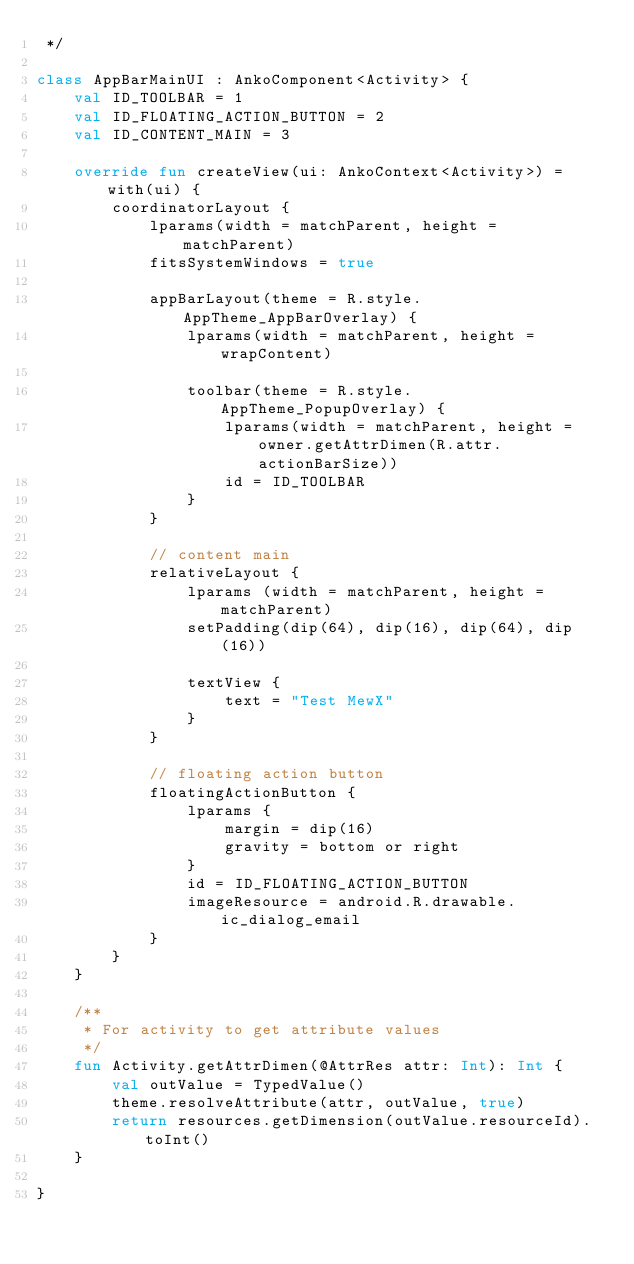<code> <loc_0><loc_0><loc_500><loc_500><_Kotlin_> */

class AppBarMainUI : AnkoComponent<Activity> {
    val ID_TOOLBAR = 1
    val ID_FLOATING_ACTION_BUTTON = 2
    val ID_CONTENT_MAIN = 3

    override fun createView(ui: AnkoContext<Activity>) = with(ui) {
        coordinatorLayout {
            lparams(width = matchParent, height = matchParent)
            fitsSystemWindows = true

            appBarLayout(theme = R.style.AppTheme_AppBarOverlay) {
                lparams(width = matchParent, height = wrapContent)

                toolbar(theme = R.style.AppTheme_PopupOverlay) {
                    lparams(width = matchParent, height = owner.getAttrDimen(R.attr.actionBarSize))
                    id = ID_TOOLBAR
                }
            }

            // content main
            relativeLayout {
                lparams (width = matchParent, height = matchParent)
                setPadding(dip(64), dip(16), dip(64), dip(16))

                textView {
                    text = "Test MewX"
                }
            }

            // floating action button
            floatingActionButton {
                lparams {
                    margin = dip(16)
                    gravity = bottom or right
                }
                id = ID_FLOATING_ACTION_BUTTON
                imageResource = android.R.drawable.ic_dialog_email
            }
        }
    }

    /**
     * For activity to get attribute values
     */
    fun Activity.getAttrDimen(@AttrRes attr: Int): Int {
        val outValue = TypedValue()
        theme.resolveAttribute(attr, outValue, true)
        return resources.getDimension(outValue.resourceId).toInt()
    }

}
</code> 